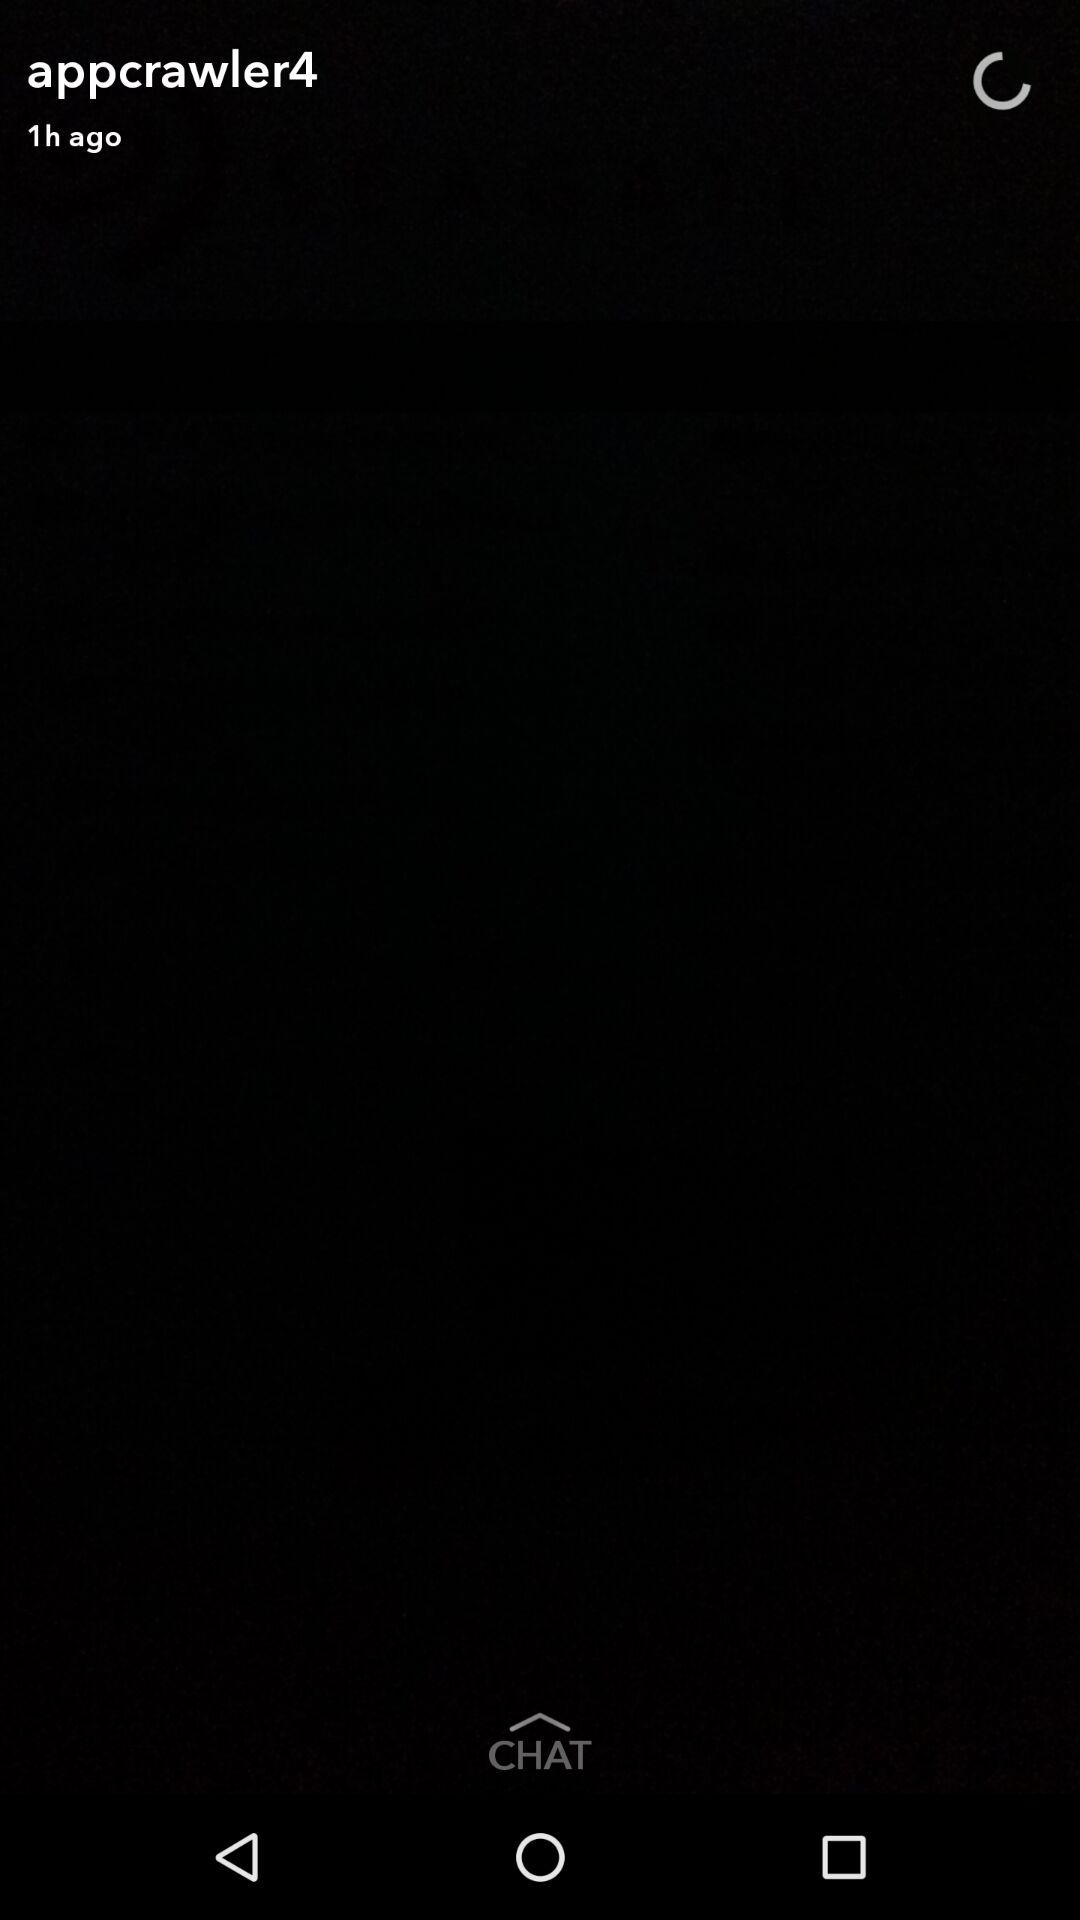What is the name of the user? The name of the user is "appcrawler4". 